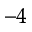<formula> <loc_0><loc_0><loc_500><loc_500>^ { - 4 }</formula> 